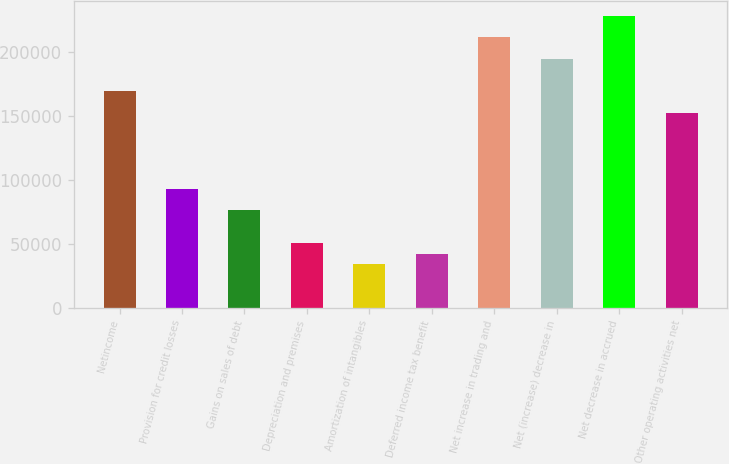Convert chart to OTSL. <chart><loc_0><loc_0><loc_500><loc_500><bar_chart><fcel>Netincome<fcel>Provision for credit losses<fcel>Gains on sales of debt<fcel>Depreciation and premises<fcel>Amortization of intangibles<fcel>Deferred income tax benefit<fcel>Net increase in trading and<fcel>Net (increase) decrease in<fcel>Net decrease in accrued<fcel>Other operating activities net<nl><fcel>169130<fcel>93023.3<fcel>76110.7<fcel>50741.8<fcel>33829.2<fcel>42285.5<fcel>211412<fcel>194499<fcel>228324<fcel>152217<nl></chart> 